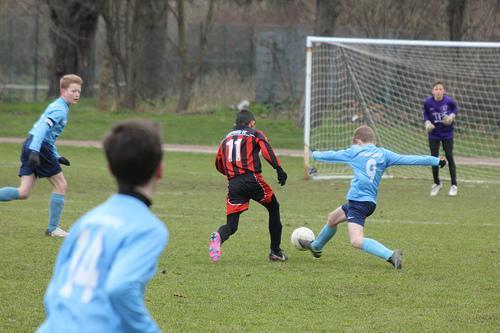How many people are in this picture?
Give a very brief answer. 5. How many kids are wearing light blue shirts?
Give a very brief answer. 3. 